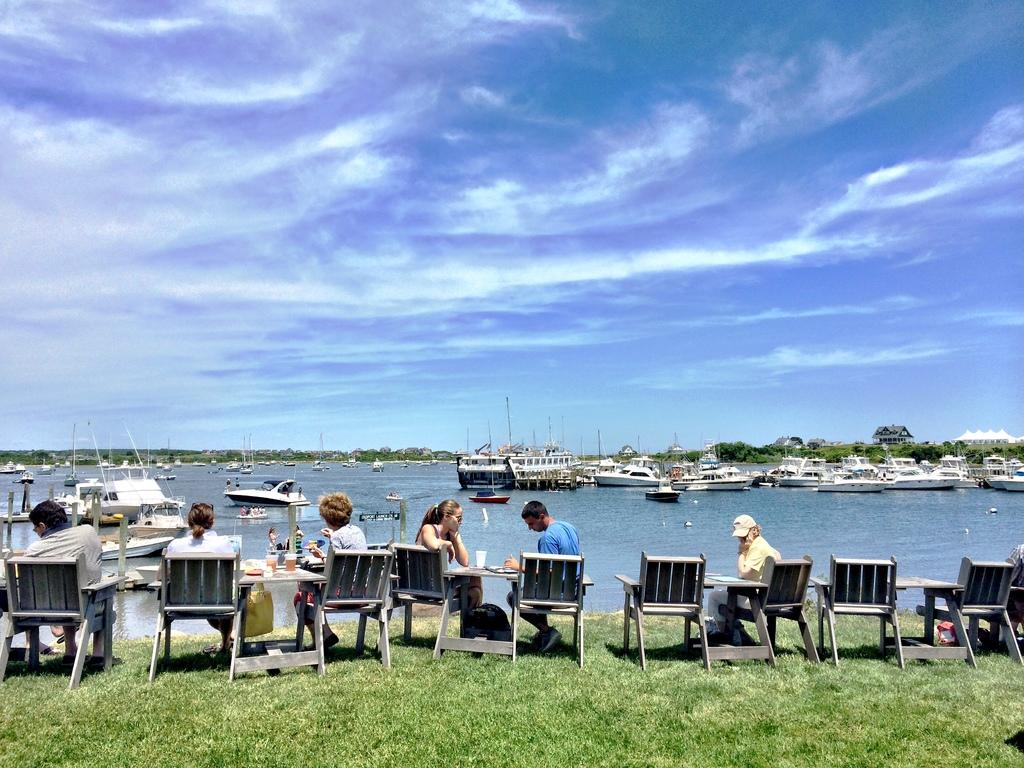What are the men in the image doing? The men in the image are sitting on chairs. How are the chairs arranged in relation to the table? The chairs are arranged around the table. What is the location of the table in the image? The table is in front of the sea. What can be seen in the sea? Ships are visible in the sea. What is the condition of the sky in the image? The sky is filled with clouds. What type of slope can be seen in the image? There is no slope present in the image. How many times do the men sneeze in the image? There is no indication of anyone sneezing in the image. 